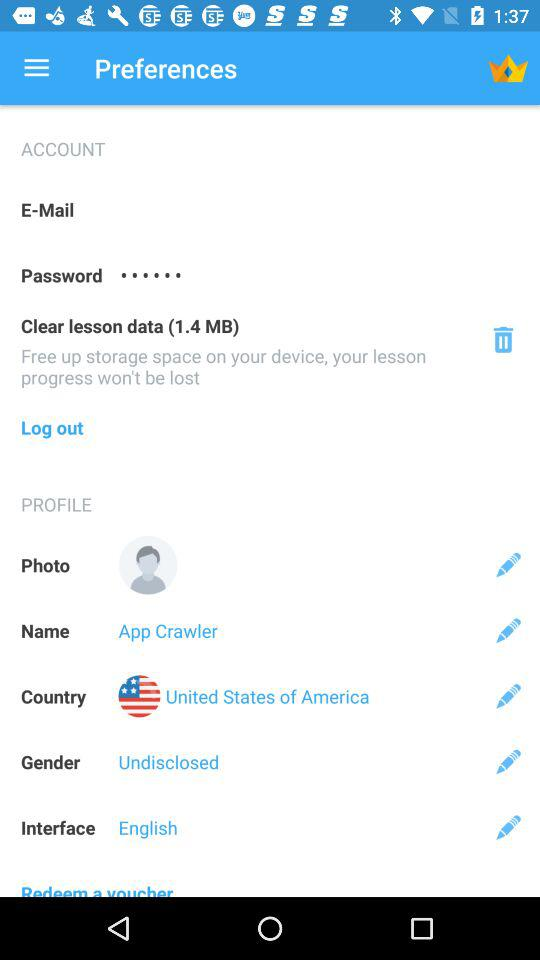What is the interface language? The interface language is English. 